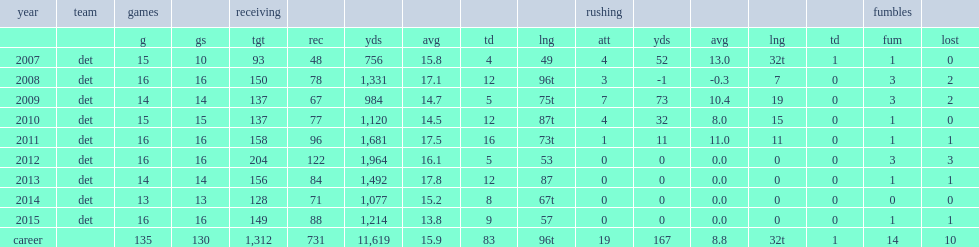How many receiving yards did calvin johnson get in 11,619? 11619.0. 